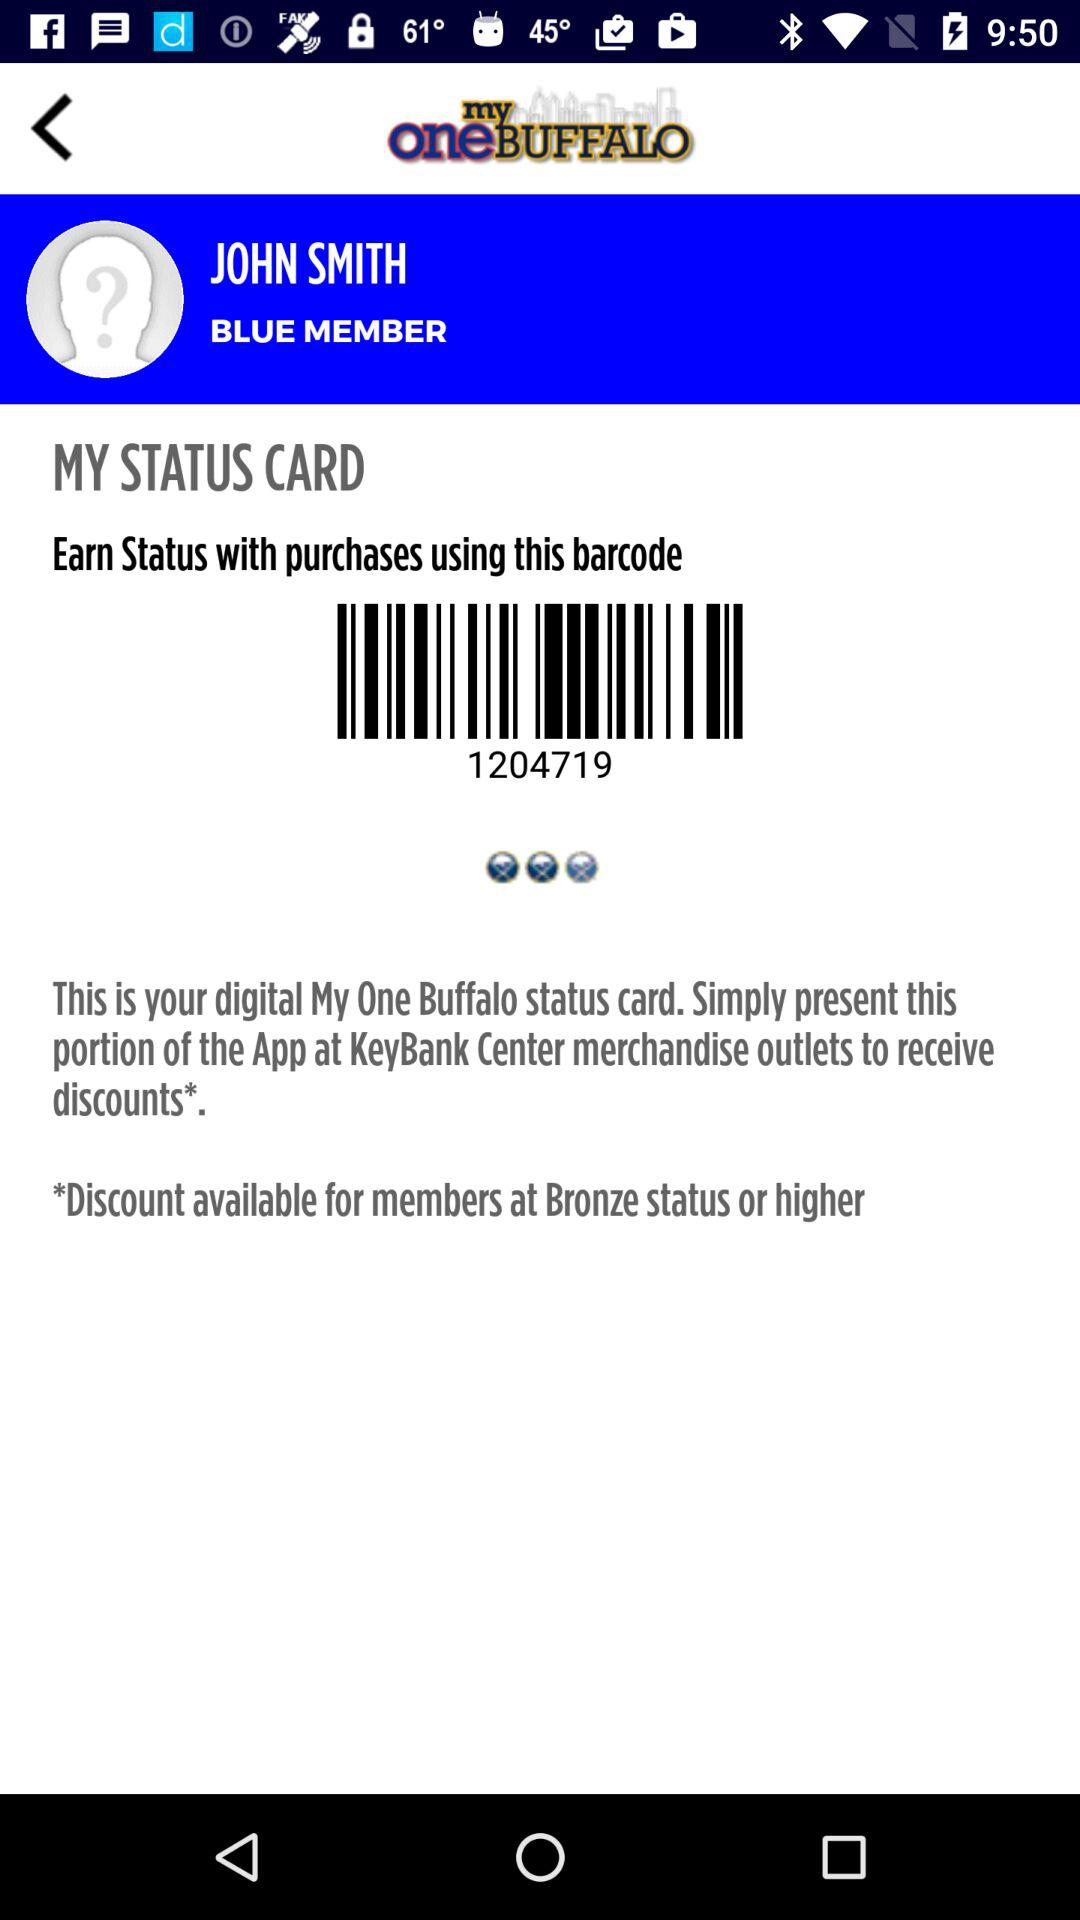What is the user name? The user name is John Smith. 